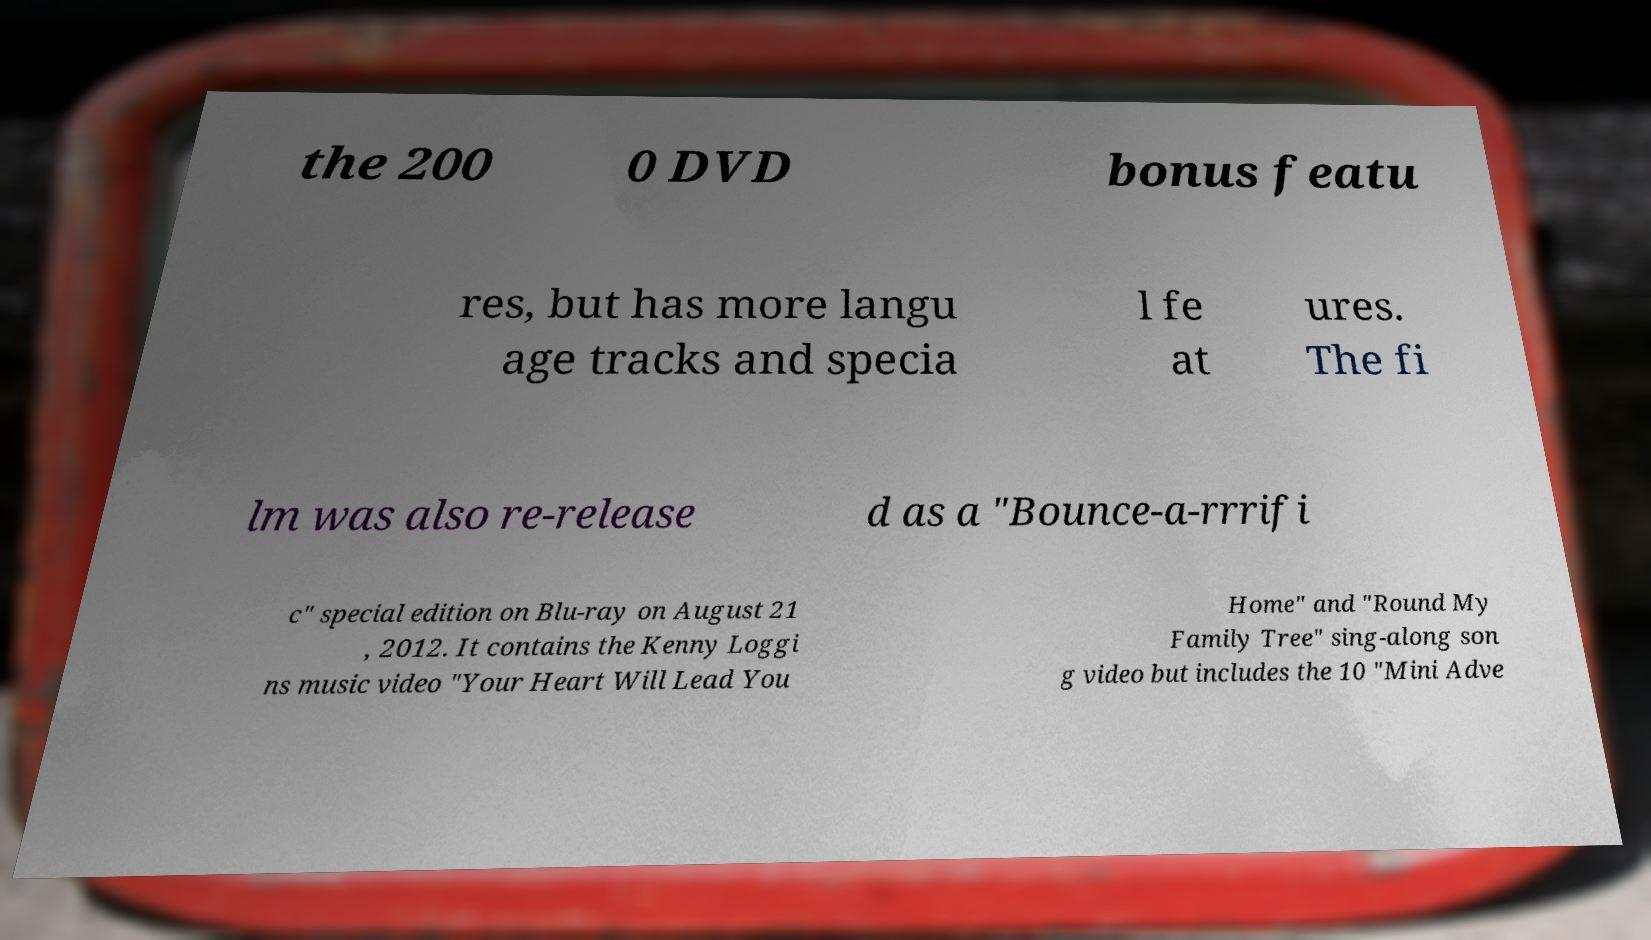Can you accurately transcribe the text from the provided image for me? the 200 0 DVD bonus featu res, but has more langu age tracks and specia l fe at ures. The fi lm was also re-release d as a "Bounce-a-rrrifi c" special edition on Blu-ray on August 21 , 2012. It contains the Kenny Loggi ns music video "Your Heart Will Lead You Home" and "Round My Family Tree" sing-along son g video but includes the 10 "Mini Adve 